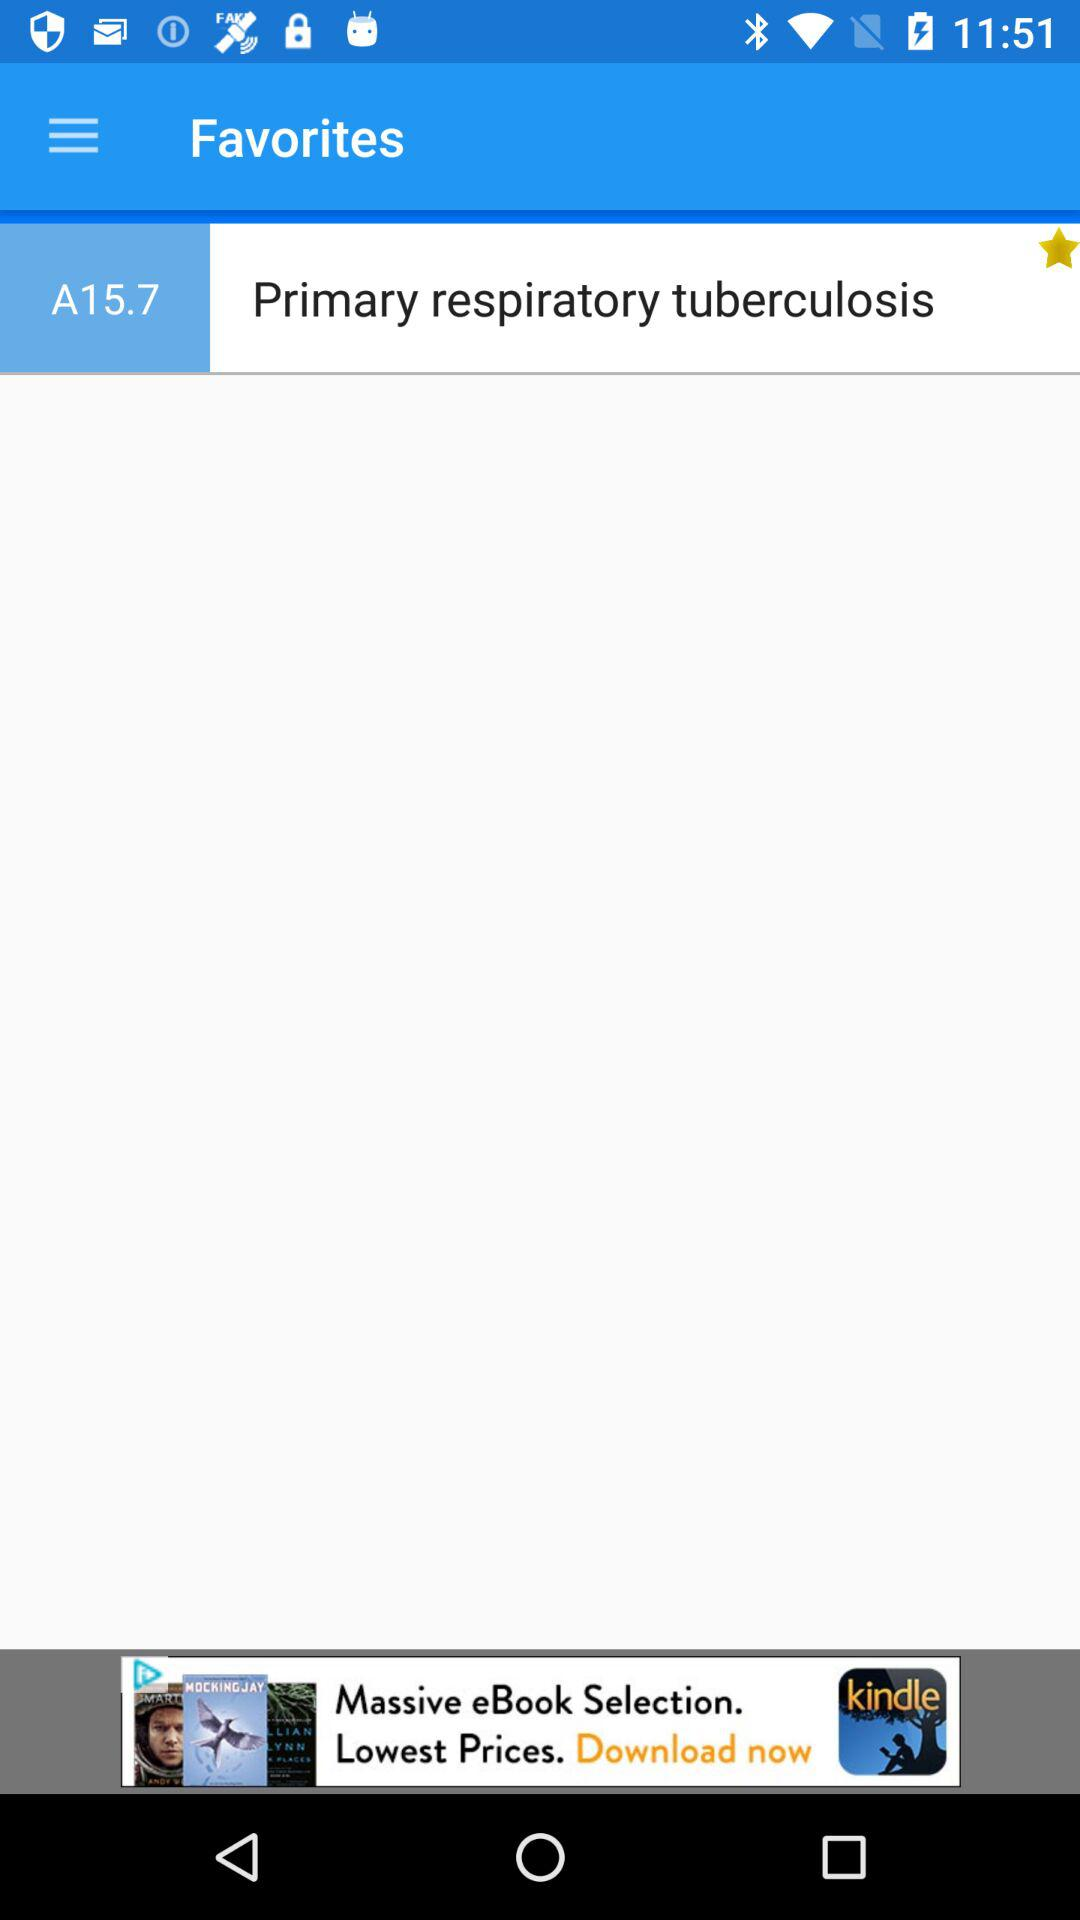What is on the favorite list? The favorite list contains "Primary respiratory tuberculosis". 